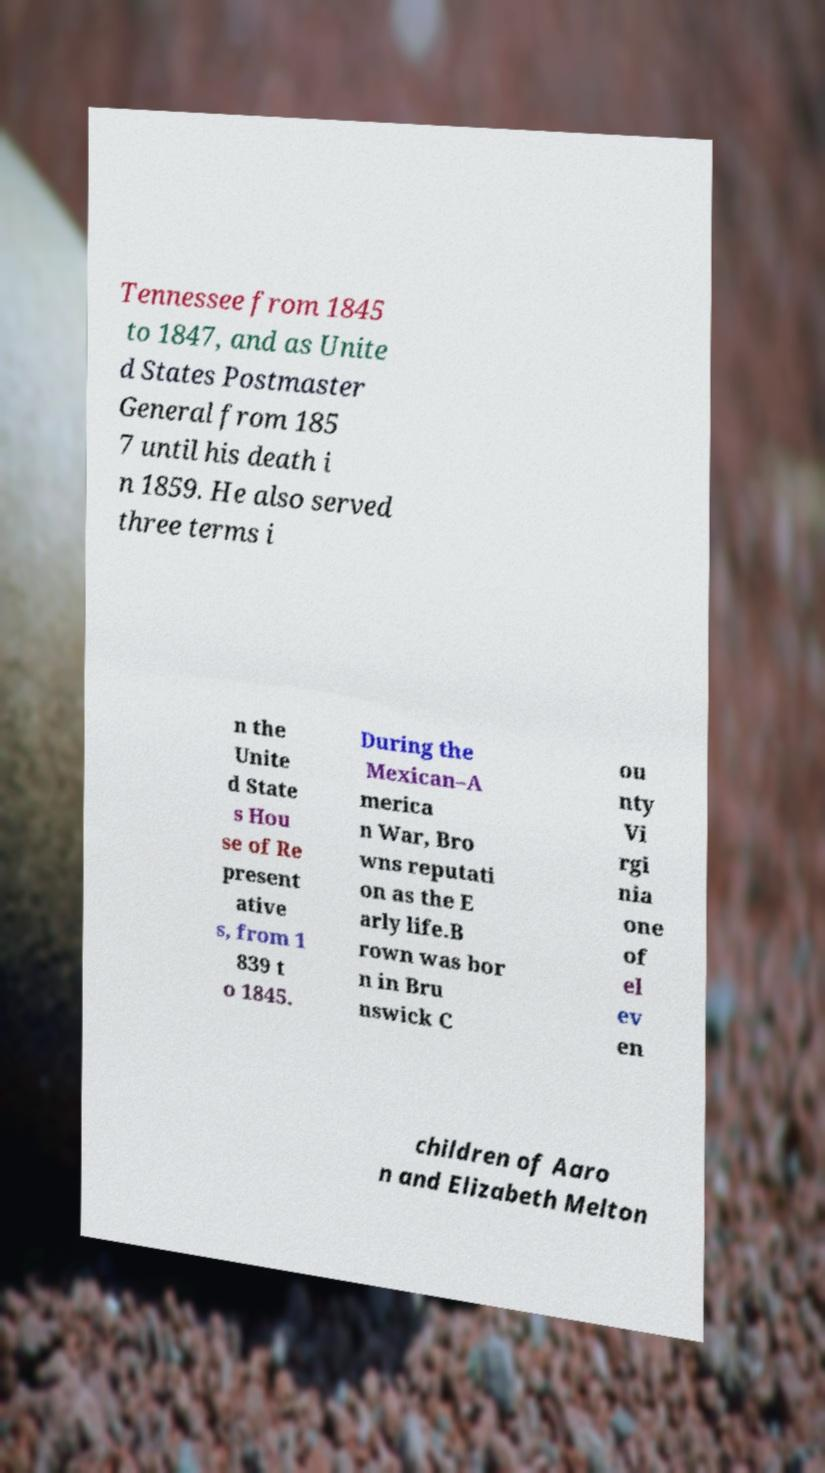Could you assist in decoding the text presented in this image and type it out clearly? Tennessee from 1845 to 1847, and as Unite d States Postmaster General from 185 7 until his death i n 1859. He also served three terms i n the Unite d State s Hou se of Re present ative s, from 1 839 t o 1845. During the Mexican–A merica n War, Bro wns reputati on as the E arly life.B rown was bor n in Bru nswick C ou nty Vi rgi nia one of el ev en children of Aaro n and Elizabeth Melton 